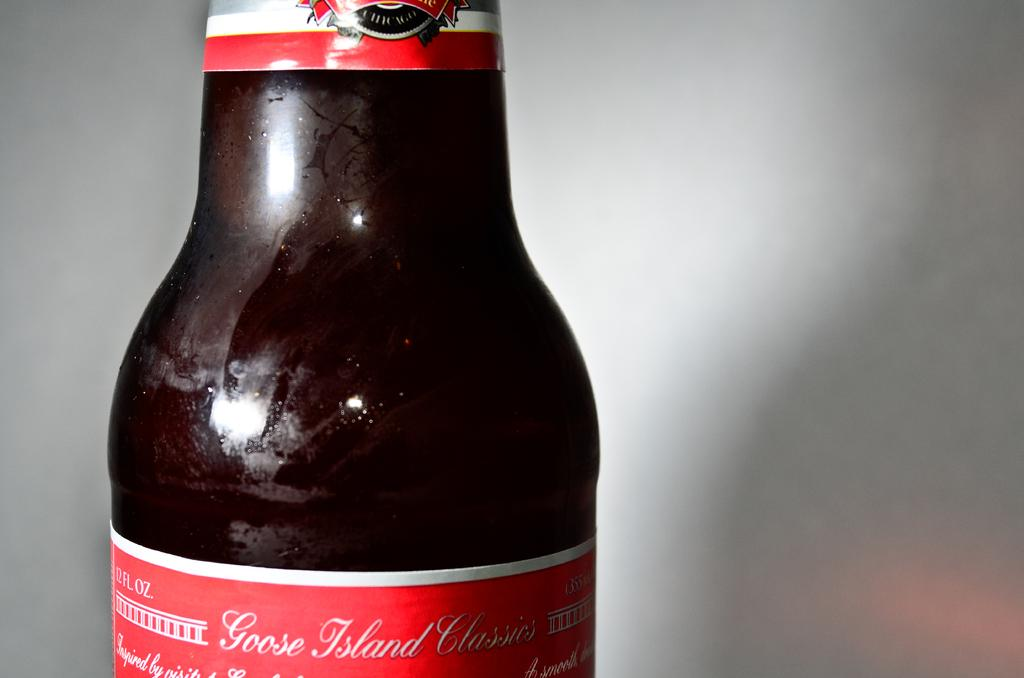<image>
Give a short and clear explanation of the subsequent image. a close up of the neck of a beer bottle for Goose Island Classic 